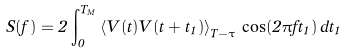Convert formula to latex. <formula><loc_0><loc_0><loc_500><loc_500>S ( f ) = 2 \int ^ { T _ { M } } _ { 0 } { \left \langle { V ( t ) V ( t + t _ { 1 } ) } \right \rangle _ { T - \tau } \, \cos ( { 2 \pi f t _ { 1 } } ) \, d t _ { 1 } }</formula> 